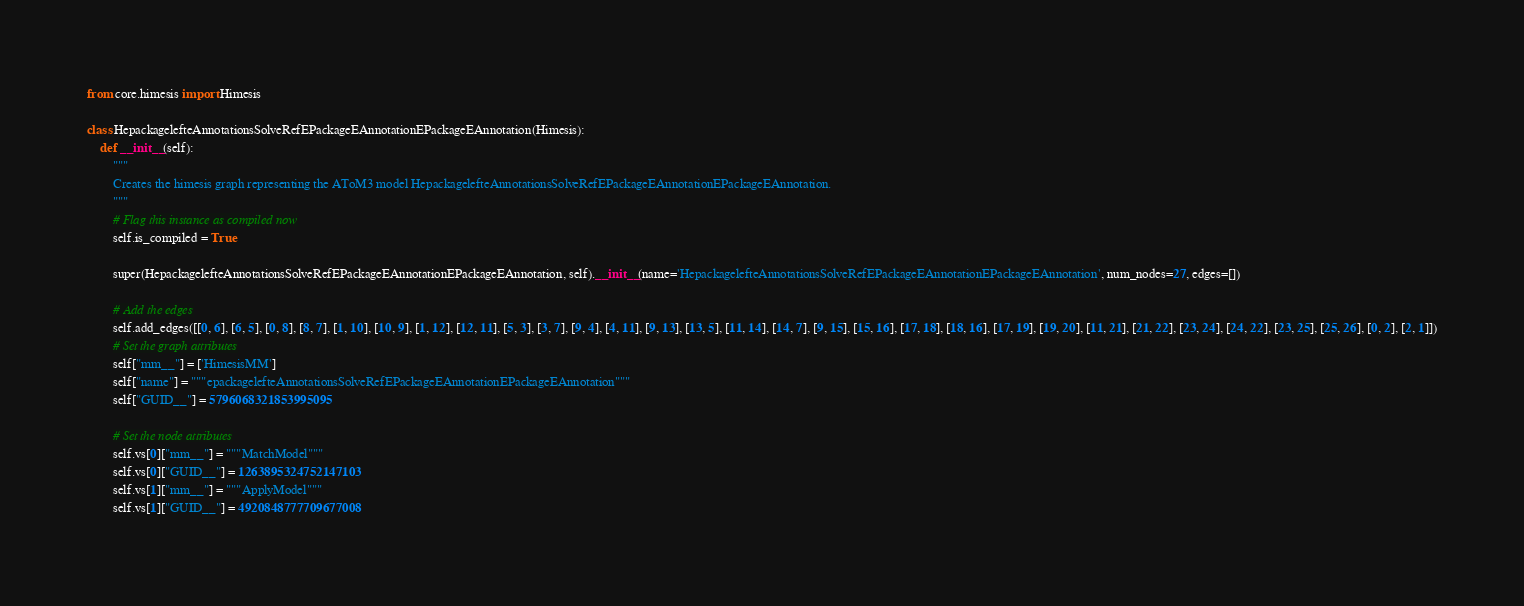Convert code to text. <code><loc_0><loc_0><loc_500><loc_500><_Python_>

from core.himesis import Himesis

class HepackagelefteAnnotationsSolveRefEPackageEAnnotationEPackageEAnnotation(Himesis):
    def __init__(self):
        """
        Creates the himesis graph representing the AToM3 model HepackagelefteAnnotationsSolveRefEPackageEAnnotationEPackageEAnnotation.
        """
        # Flag this instance as compiled now
        self.is_compiled = True
        
        super(HepackagelefteAnnotationsSolveRefEPackageEAnnotationEPackageEAnnotation, self).__init__(name='HepackagelefteAnnotationsSolveRefEPackageEAnnotationEPackageEAnnotation', num_nodes=27, edges=[])
        
        # Add the edges
        self.add_edges([[0, 6], [6, 5], [0, 8], [8, 7], [1, 10], [10, 9], [1, 12], [12, 11], [5, 3], [3, 7], [9, 4], [4, 11], [9, 13], [13, 5], [11, 14], [14, 7], [9, 15], [15, 16], [17, 18], [18, 16], [17, 19], [19, 20], [11, 21], [21, 22], [23, 24], [24, 22], [23, 25], [25, 26], [0, 2], [2, 1]])
        # Set the graph attributes
        self["mm__"] = ['HimesisMM']
        self["name"] = """epackagelefteAnnotationsSolveRefEPackageEAnnotationEPackageEAnnotation"""
        self["GUID__"] = 5796068321853995095
        
        # Set the node attributes
        self.vs[0]["mm__"] = """MatchModel"""
        self.vs[0]["GUID__"] = 1263895324752147103
        self.vs[1]["mm__"] = """ApplyModel"""
        self.vs[1]["GUID__"] = 4920848777709677008</code> 